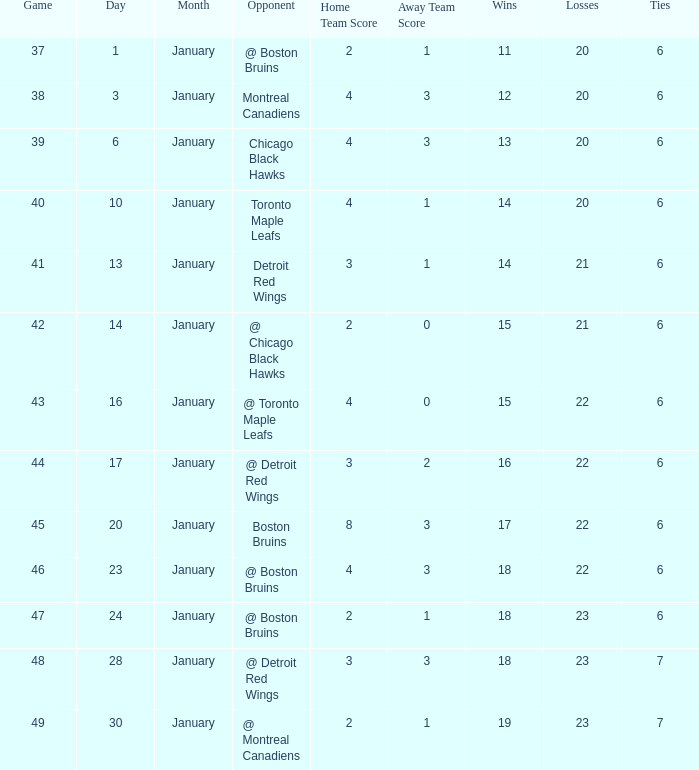What day in January was the game greater than 49 and had @ Montreal Canadiens as opponents? None. 